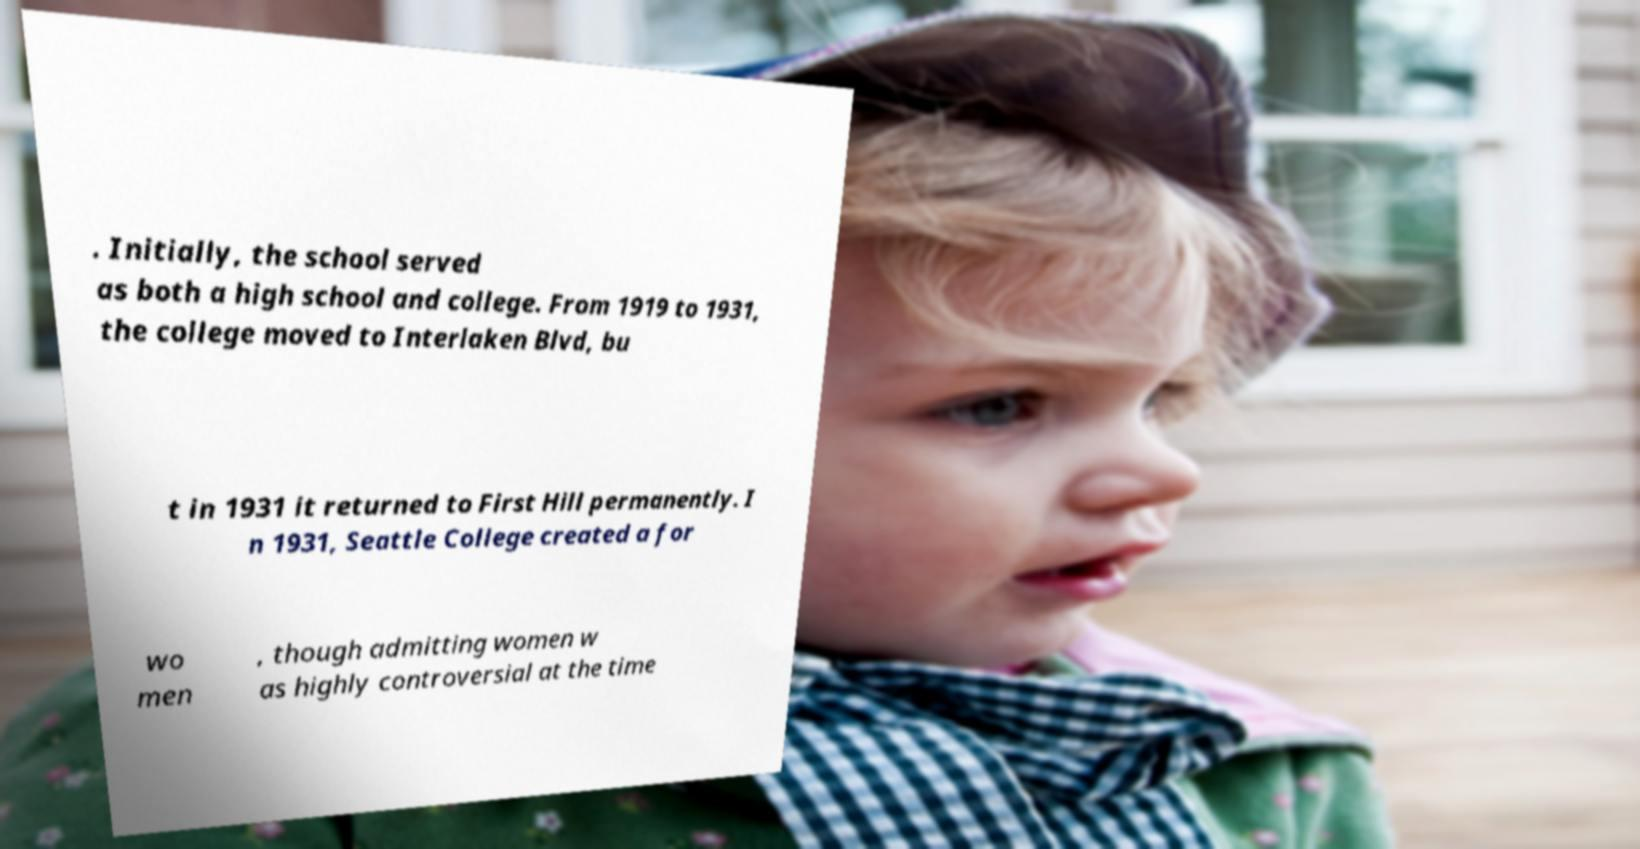Please read and relay the text visible in this image. What does it say? . Initially, the school served as both a high school and college. From 1919 to 1931, the college moved to Interlaken Blvd, bu t in 1931 it returned to First Hill permanently. I n 1931, Seattle College created a for wo men , though admitting women w as highly controversial at the time 